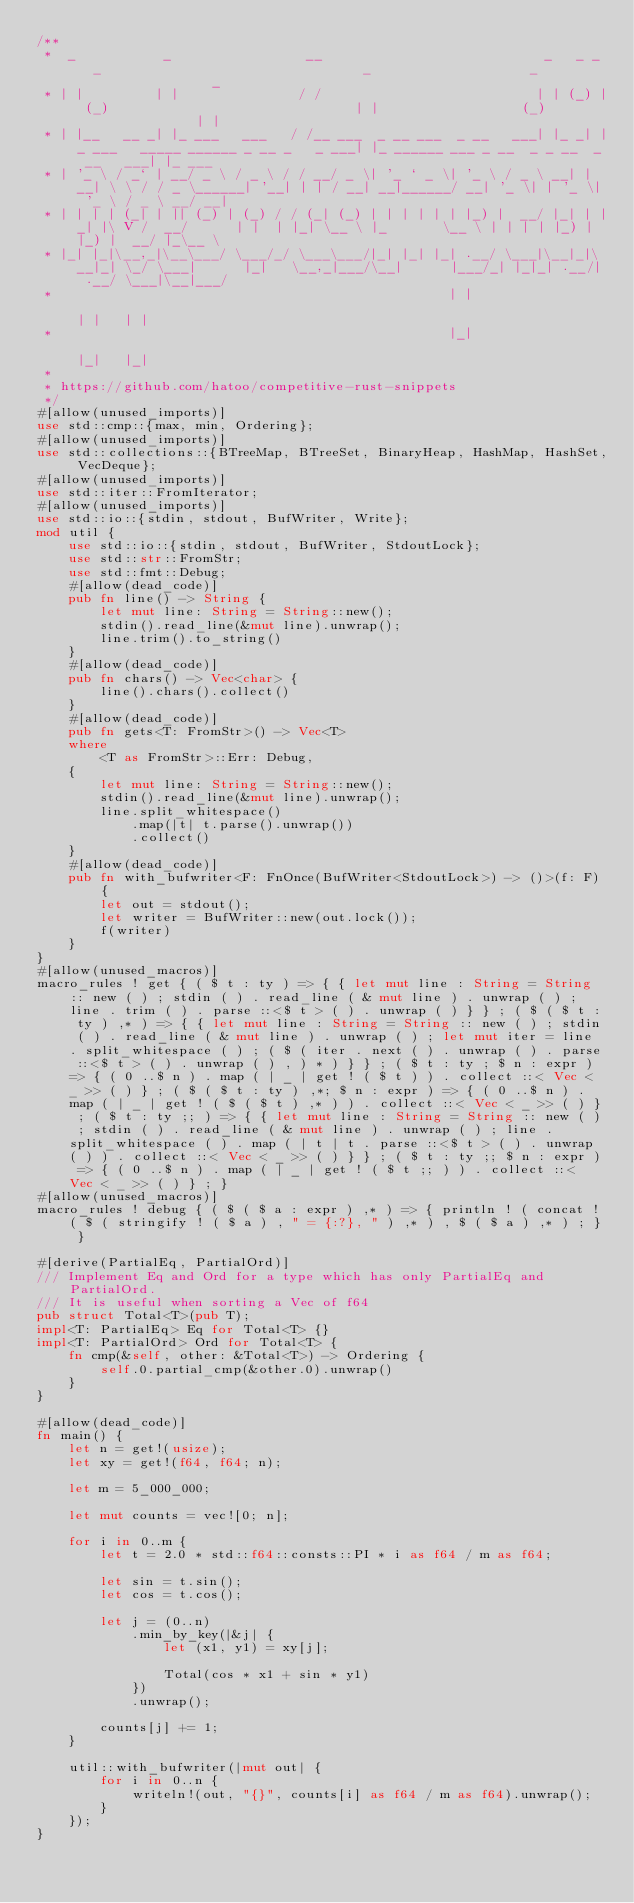<code> <loc_0><loc_0><loc_500><loc_500><_Rust_>/**
 *  _           _                 __                            _   _ _   _                                 _                    _                  _
 * | |         | |               / /                           | | (_) | (_)                               | |                  (_)                | |
 * | |__   __ _| |_ ___   ___   / /__ ___  _ __ ___  _ __   ___| |_ _| |_ ___   _____ ______ _ __ _   _ ___| |_ ______ ___ _ __  _ _ __  _ __   ___| |_ ___
 * | '_ \ / _` | __/ _ \ / _ \ / / __/ _ \| '_ ` _ \| '_ \ / _ \ __| | __| \ \ / / _ \______| '__| | | / __| __|______/ __| '_ \| | '_ \| '_ \ / _ \ __/ __|
 * | | | | (_| | || (_) | (_) / / (_| (_) | | | | | | |_) |  __/ |_| | |_| |\ V /  __/      | |  | |_| \__ \ |_       \__ \ | | | | |_) | |_) |  __/ |_\__ \
 * |_| |_|\__,_|\__\___/ \___/_/ \___\___/|_| |_| |_| .__/ \___|\__|_|\__|_| \_/ \___|      |_|   \__,_|___/\__|      |___/_| |_|_| .__/| .__/ \___|\__|___/
 *                                                  | |                                                                           | |   | |
 *                                                  |_|                                                                           |_|   |_|
 *
 * https://github.com/hatoo/competitive-rust-snippets
 */
#[allow(unused_imports)]
use std::cmp::{max, min, Ordering};
#[allow(unused_imports)]
use std::collections::{BTreeMap, BTreeSet, BinaryHeap, HashMap, HashSet, VecDeque};
#[allow(unused_imports)]
use std::iter::FromIterator;
#[allow(unused_imports)]
use std::io::{stdin, stdout, BufWriter, Write};
mod util {
    use std::io::{stdin, stdout, BufWriter, StdoutLock};
    use std::str::FromStr;
    use std::fmt::Debug;
    #[allow(dead_code)]
    pub fn line() -> String {
        let mut line: String = String::new();
        stdin().read_line(&mut line).unwrap();
        line.trim().to_string()
    }
    #[allow(dead_code)]
    pub fn chars() -> Vec<char> {
        line().chars().collect()
    }
    #[allow(dead_code)]
    pub fn gets<T: FromStr>() -> Vec<T>
    where
        <T as FromStr>::Err: Debug,
    {
        let mut line: String = String::new();
        stdin().read_line(&mut line).unwrap();
        line.split_whitespace()
            .map(|t| t.parse().unwrap())
            .collect()
    }
    #[allow(dead_code)]
    pub fn with_bufwriter<F: FnOnce(BufWriter<StdoutLock>) -> ()>(f: F) {
        let out = stdout();
        let writer = BufWriter::new(out.lock());
        f(writer)
    }
}
#[allow(unused_macros)]
macro_rules ! get { ( $ t : ty ) => { { let mut line : String = String :: new ( ) ; stdin ( ) . read_line ( & mut line ) . unwrap ( ) ; line . trim ( ) . parse ::<$ t > ( ) . unwrap ( ) } } ; ( $ ( $ t : ty ) ,* ) => { { let mut line : String = String :: new ( ) ; stdin ( ) . read_line ( & mut line ) . unwrap ( ) ; let mut iter = line . split_whitespace ( ) ; ( $ ( iter . next ( ) . unwrap ( ) . parse ::<$ t > ( ) . unwrap ( ) , ) * ) } } ; ( $ t : ty ; $ n : expr ) => { ( 0 ..$ n ) . map ( | _ | get ! ( $ t ) ) . collect ::< Vec < _ >> ( ) } ; ( $ ( $ t : ty ) ,*; $ n : expr ) => { ( 0 ..$ n ) . map ( | _ | get ! ( $ ( $ t ) ,* ) ) . collect ::< Vec < _ >> ( ) } ; ( $ t : ty ;; ) => { { let mut line : String = String :: new ( ) ; stdin ( ) . read_line ( & mut line ) . unwrap ( ) ; line . split_whitespace ( ) . map ( | t | t . parse ::<$ t > ( ) . unwrap ( ) ) . collect ::< Vec < _ >> ( ) } } ; ( $ t : ty ;; $ n : expr ) => { ( 0 ..$ n ) . map ( | _ | get ! ( $ t ;; ) ) . collect ::< Vec < _ >> ( ) } ; }
#[allow(unused_macros)]
macro_rules ! debug { ( $ ( $ a : expr ) ,* ) => { println ! ( concat ! ( $ ( stringify ! ( $ a ) , " = {:?}, " ) ,* ) , $ ( $ a ) ,* ) ; } }

#[derive(PartialEq, PartialOrd)]
/// Implement Eq and Ord for a type which has only PartialEq and PartialOrd.
/// It is useful when sorting a Vec of f64
pub struct Total<T>(pub T);
impl<T: PartialEq> Eq for Total<T> {}
impl<T: PartialOrd> Ord for Total<T> {
    fn cmp(&self, other: &Total<T>) -> Ordering {
        self.0.partial_cmp(&other.0).unwrap()
    }
}

#[allow(dead_code)]
fn main() {
    let n = get!(usize);
    let xy = get!(f64, f64; n);

    let m = 5_000_000;

    let mut counts = vec![0; n];

    for i in 0..m {
        let t = 2.0 * std::f64::consts::PI * i as f64 / m as f64;

        let sin = t.sin();
        let cos = t.cos();

        let j = (0..n)
            .min_by_key(|&j| {
                let (x1, y1) = xy[j];

                Total(cos * x1 + sin * y1)
            })
            .unwrap();

        counts[j] += 1;
    }

    util::with_bufwriter(|mut out| {
        for i in 0..n {
            writeln!(out, "{}", counts[i] as f64 / m as f64).unwrap();
        }
    });
}
</code> 